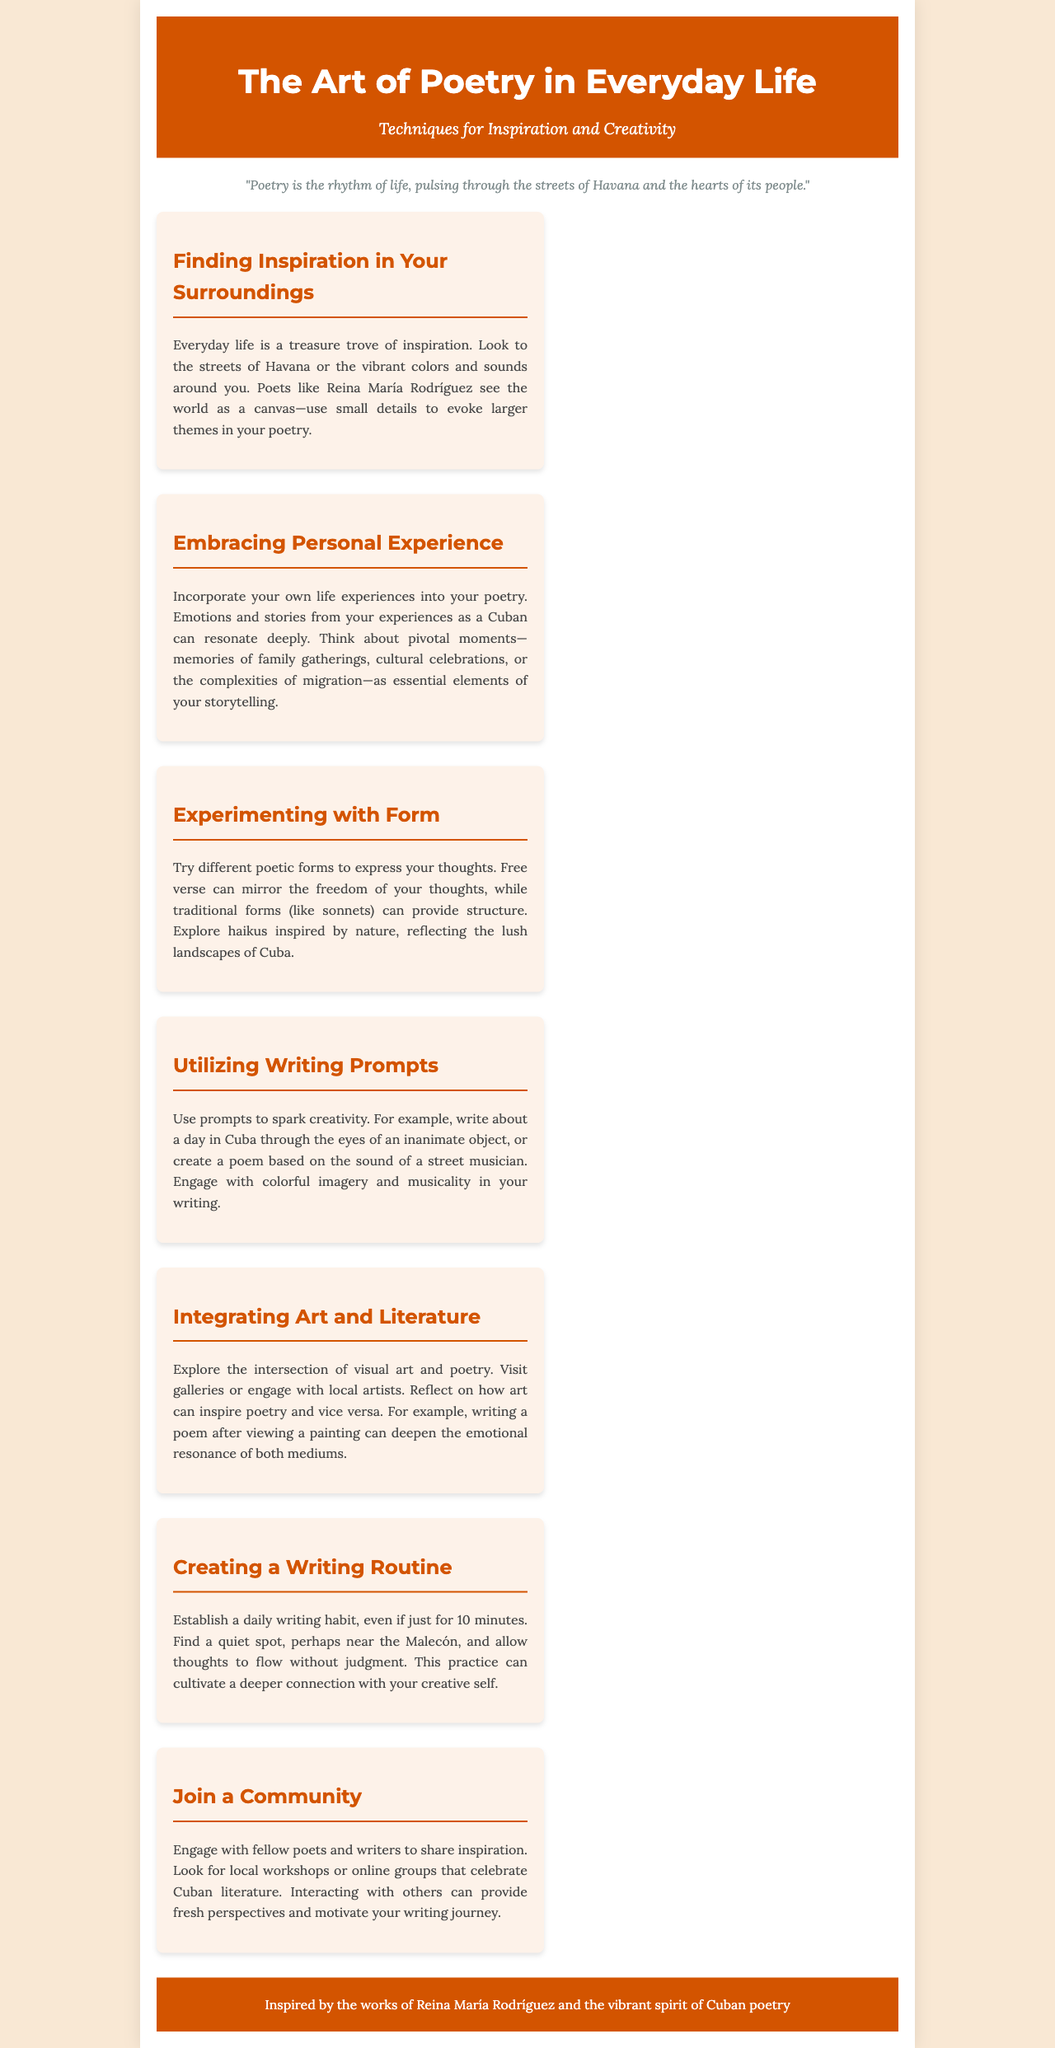What is the title of the brochure? The title of the brochure is prominently displayed at the top of the document, which is about poetry.
Answer: The Art of Poetry in Everyday Life Who is an inspirational poet mentioned in the brochure? The brochure highlights Reina María Rodríguez as a source of inspiration.
Answer: Reina María Rodríguez What is suggested for finding inspiration in your surroundings? The document encourages looking at your everyday surroundings for poetic inspiration, particularly in Havana.
Answer: The streets of Havana What forms of poetry are suggested for experimentation? The brochure mentions various poetic forms, including free verse and traditional forms.
Answer: Free verse and sonnets What should a daily writing habit ideally consist of? The guidance in the brochure emphasizes having a daily writing routine, even for a short duration.
Answer: 10 minutes What kind of community engagement is encouraged? The brochure advises joining workshops or online groups to interact with fellow writers and poets.
Answer: Local workshops What intersection does the brochure suggest exploring? The document encourages exploring how visual art and poetry can inspire each other.
Answer: Art and literature What is one writing prompt suggested in the brochure? The brochure provides prompts to stimulate creativity, giving examples of related ideas.
Answer: A day in Cuba through the eyes of an inanimate object 